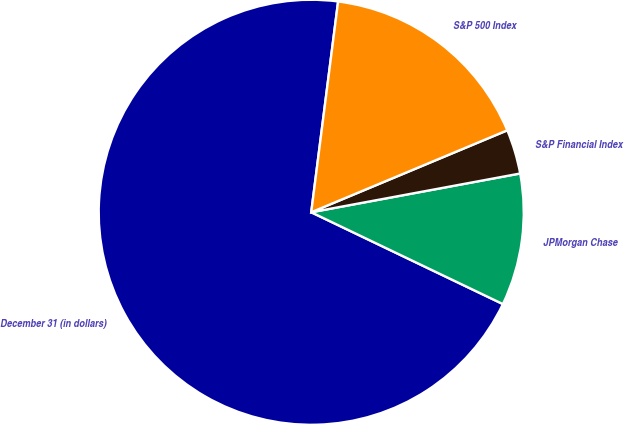<chart> <loc_0><loc_0><loc_500><loc_500><pie_chart><fcel>December 31 (in dollars)<fcel>JPMorgan Chase<fcel>S&P Financial Index<fcel>S&P 500 Index<nl><fcel>69.91%<fcel>10.03%<fcel>3.38%<fcel>16.68%<nl></chart> 